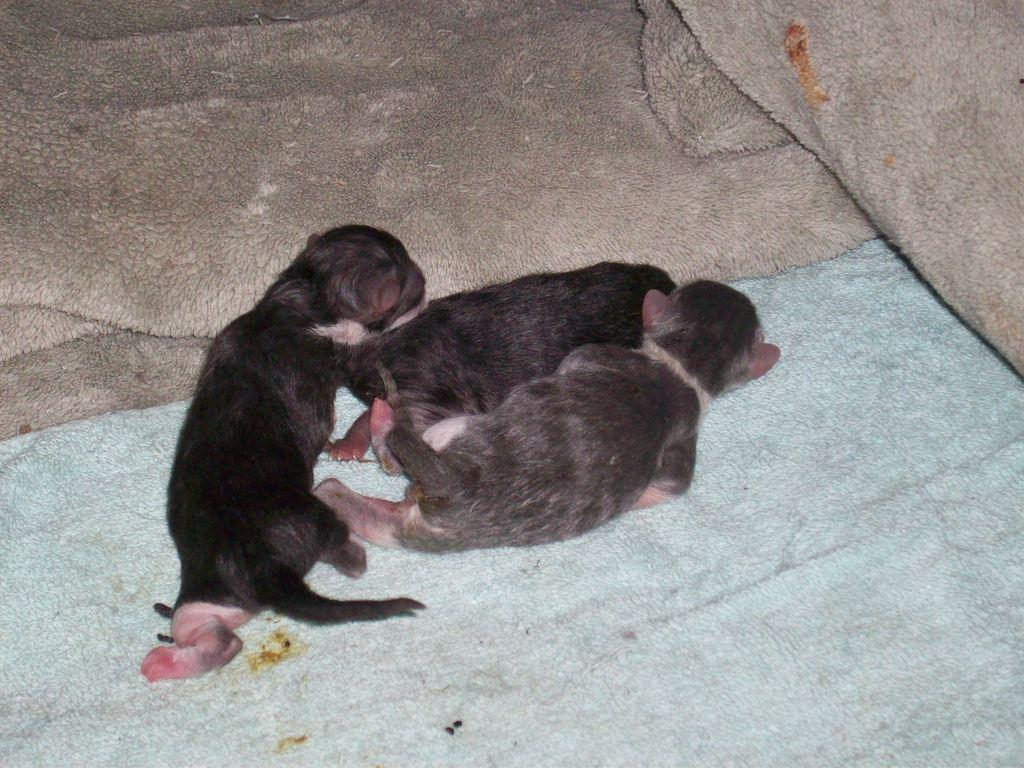What type of animals are present in the image? There are three black animals in the image. Where are the animals located? The animals are laying on a bed sheet. How many bed sheets are visible in the image? There are two additional bed sheets visible in the image. What type of game is being played on the bed sheet in the image? There is no game being played in the image; it simply shows three black animals laying on a bed sheet. 